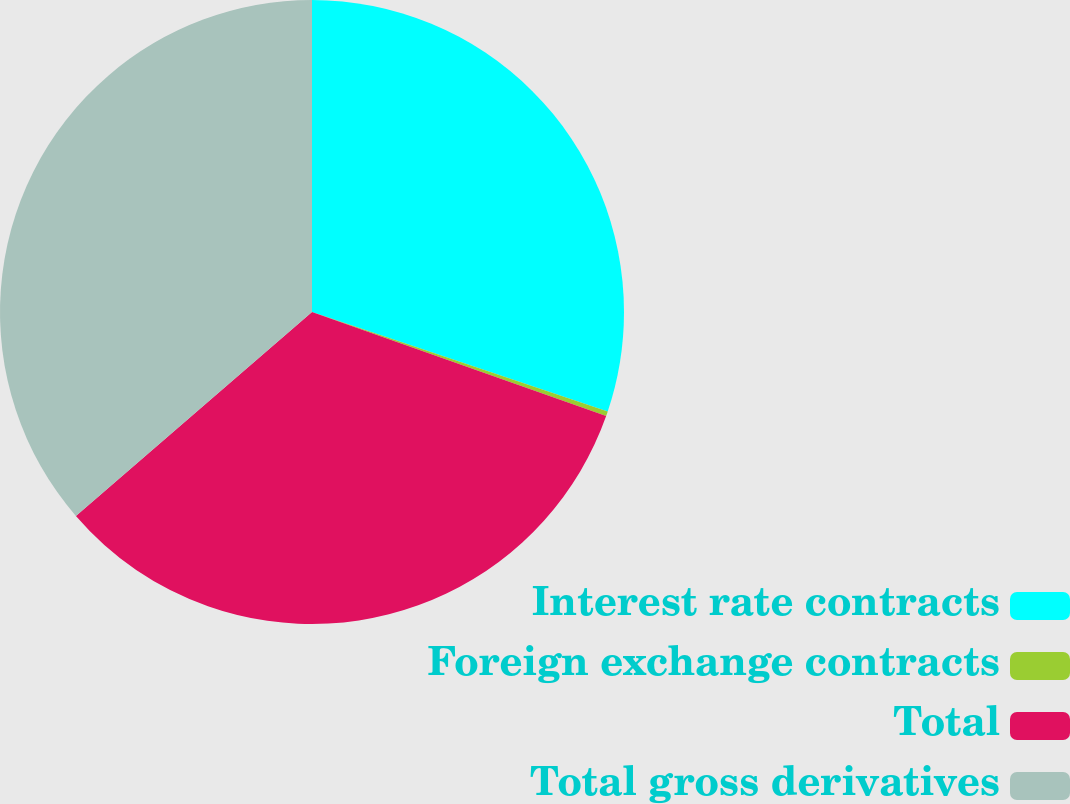Convert chart to OTSL. <chart><loc_0><loc_0><loc_500><loc_500><pie_chart><fcel>Interest rate contracts<fcel>Foreign exchange contracts<fcel>Total<fcel>Total gross derivatives<nl><fcel>30.16%<fcel>0.25%<fcel>33.25%<fcel>36.34%<nl></chart> 